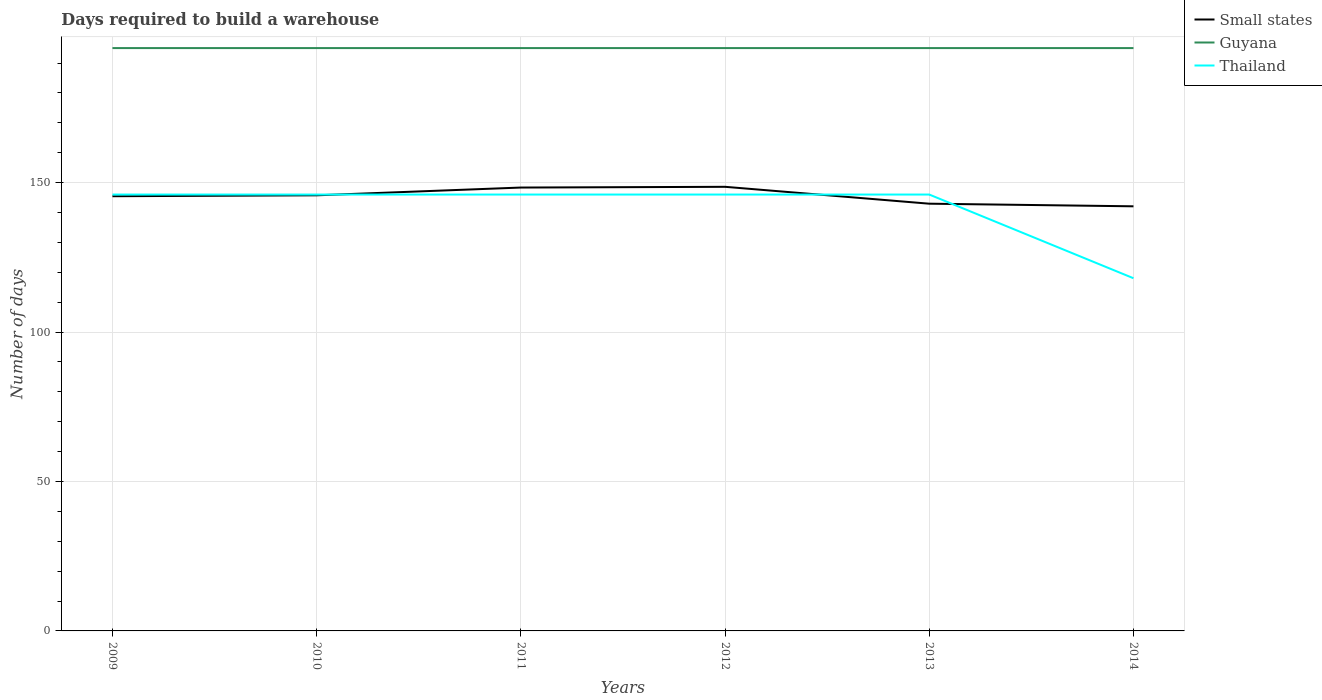Does the line corresponding to Guyana intersect with the line corresponding to Small states?
Provide a succinct answer. No. Across all years, what is the maximum days required to build a warehouse in in Guyana?
Provide a short and direct response. 195. What is the total days required to build a warehouse in in Guyana in the graph?
Give a very brief answer. 0. What is the difference between the highest and the second highest days required to build a warehouse in in Small states?
Your response must be concise. 6.53. What is the difference between the highest and the lowest days required to build a warehouse in in Small states?
Provide a short and direct response. 3. What is the difference between two consecutive major ticks on the Y-axis?
Keep it short and to the point. 50. Are the values on the major ticks of Y-axis written in scientific E-notation?
Keep it short and to the point. No. Does the graph contain any zero values?
Your answer should be compact. No. How many legend labels are there?
Offer a terse response. 3. How are the legend labels stacked?
Your answer should be very brief. Vertical. What is the title of the graph?
Make the answer very short. Days required to build a warehouse. What is the label or title of the Y-axis?
Give a very brief answer. Number of days. What is the Number of days of Small states in 2009?
Make the answer very short. 145.44. What is the Number of days in Guyana in 2009?
Offer a terse response. 195. What is the Number of days of Thailand in 2009?
Keep it short and to the point. 146. What is the Number of days in Small states in 2010?
Keep it short and to the point. 145.74. What is the Number of days of Guyana in 2010?
Make the answer very short. 195. What is the Number of days in Thailand in 2010?
Offer a terse response. 146. What is the Number of days in Small states in 2011?
Your answer should be very brief. 148.34. What is the Number of days in Guyana in 2011?
Your response must be concise. 195. What is the Number of days in Thailand in 2011?
Your answer should be compact. 146. What is the Number of days in Small states in 2012?
Your answer should be very brief. 148.59. What is the Number of days in Guyana in 2012?
Offer a very short reply. 195. What is the Number of days of Thailand in 2012?
Offer a terse response. 146. What is the Number of days of Small states in 2013?
Provide a short and direct response. 142.94. What is the Number of days in Guyana in 2013?
Offer a very short reply. 195. What is the Number of days in Thailand in 2013?
Keep it short and to the point. 146. What is the Number of days in Small states in 2014?
Make the answer very short. 142.06. What is the Number of days in Guyana in 2014?
Your response must be concise. 195. What is the Number of days in Thailand in 2014?
Offer a very short reply. 118. Across all years, what is the maximum Number of days in Small states?
Your response must be concise. 148.59. Across all years, what is the maximum Number of days of Guyana?
Provide a succinct answer. 195. Across all years, what is the maximum Number of days in Thailand?
Make the answer very short. 146. Across all years, what is the minimum Number of days of Small states?
Keep it short and to the point. 142.06. Across all years, what is the minimum Number of days in Guyana?
Your answer should be compact. 195. Across all years, what is the minimum Number of days of Thailand?
Give a very brief answer. 118. What is the total Number of days of Small states in the graph?
Your answer should be very brief. 873.1. What is the total Number of days in Guyana in the graph?
Make the answer very short. 1170. What is the total Number of days of Thailand in the graph?
Provide a short and direct response. 848. What is the difference between the Number of days of Small states in 2009 and that in 2010?
Offer a very short reply. -0.31. What is the difference between the Number of days of Thailand in 2009 and that in 2010?
Your response must be concise. 0. What is the difference between the Number of days of Small states in 2009 and that in 2011?
Provide a short and direct response. -2.9. What is the difference between the Number of days in Guyana in 2009 and that in 2011?
Give a very brief answer. 0. What is the difference between the Number of days of Thailand in 2009 and that in 2011?
Offer a very short reply. 0. What is the difference between the Number of days in Small states in 2009 and that in 2012?
Give a very brief answer. -3.15. What is the difference between the Number of days in Small states in 2009 and that in 2013?
Offer a very short reply. 2.5. What is the difference between the Number of days in Guyana in 2009 and that in 2013?
Provide a succinct answer. 0. What is the difference between the Number of days of Thailand in 2009 and that in 2013?
Your answer should be compact. 0. What is the difference between the Number of days in Small states in 2009 and that in 2014?
Give a very brief answer. 3.37. What is the difference between the Number of days of Thailand in 2009 and that in 2014?
Your answer should be very brief. 28. What is the difference between the Number of days of Small states in 2010 and that in 2011?
Keep it short and to the point. -2.59. What is the difference between the Number of days of Thailand in 2010 and that in 2011?
Your response must be concise. 0. What is the difference between the Number of days of Small states in 2010 and that in 2012?
Give a very brief answer. -2.84. What is the difference between the Number of days of Guyana in 2010 and that in 2012?
Keep it short and to the point. 0. What is the difference between the Number of days in Thailand in 2010 and that in 2012?
Your response must be concise. 0. What is the difference between the Number of days in Small states in 2010 and that in 2013?
Provide a short and direct response. 2.81. What is the difference between the Number of days of Thailand in 2010 and that in 2013?
Offer a terse response. 0. What is the difference between the Number of days in Small states in 2010 and that in 2014?
Make the answer very short. 3.68. What is the difference between the Number of days in Guyana in 2011 and that in 2012?
Your response must be concise. 0. What is the difference between the Number of days in Thailand in 2011 and that in 2012?
Give a very brief answer. 0. What is the difference between the Number of days in Small states in 2011 and that in 2014?
Make the answer very short. 6.28. What is the difference between the Number of days of Thailand in 2011 and that in 2014?
Your response must be concise. 28. What is the difference between the Number of days in Small states in 2012 and that in 2013?
Your answer should be very brief. 5.65. What is the difference between the Number of days of Guyana in 2012 and that in 2013?
Keep it short and to the point. 0. What is the difference between the Number of days in Thailand in 2012 and that in 2013?
Ensure brevity in your answer.  0. What is the difference between the Number of days in Small states in 2012 and that in 2014?
Ensure brevity in your answer.  6.53. What is the difference between the Number of days in Guyana in 2012 and that in 2014?
Your response must be concise. 0. What is the difference between the Number of days of Thailand in 2012 and that in 2014?
Your response must be concise. 28. What is the difference between the Number of days in Small states in 2009 and the Number of days in Guyana in 2010?
Provide a succinct answer. -49.56. What is the difference between the Number of days of Small states in 2009 and the Number of days of Thailand in 2010?
Ensure brevity in your answer.  -0.56. What is the difference between the Number of days of Small states in 2009 and the Number of days of Guyana in 2011?
Ensure brevity in your answer.  -49.56. What is the difference between the Number of days in Small states in 2009 and the Number of days in Thailand in 2011?
Your answer should be compact. -0.56. What is the difference between the Number of days in Guyana in 2009 and the Number of days in Thailand in 2011?
Provide a short and direct response. 49. What is the difference between the Number of days of Small states in 2009 and the Number of days of Guyana in 2012?
Ensure brevity in your answer.  -49.56. What is the difference between the Number of days in Small states in 2009 and the Number of days in Thailand in 2012?
Your response must be concise. -0.56. What is the difference between the Number of days in Small states in 2009 and the Number of days in Guyana in 2013?
Your answer should be very brief. -49.56. What is the difference between the Number of days of Small states in 2009 and the Number of days of Thailand in 2013?
Provide a succinct answer. -0.56. What is the difference between the Number of days of Guyana in 2009 and the Number of days of Thailand in 2013?
Ensure brevity in your answer.  49. What is the difference between the Number of days in Small states in 2009 and the Number of days in Guyana in 2014?
Make the answer very short. -49.56. What is the difference between the Number of days in Small states in 2009 and the Number of days in Thailand in 2014?
Provide a succinct answer. 27.44. What is the difference between the Number of days in Guyana in 2009 and the Number of days in Thailand in 2014?
Your answer should be very brief. 77. What is the difference between the Number of days in Small states in 2010 and the Number of days in Guyana in 2011?
Give a very brief answer. -49.26. What is the difference between the Number of days in Small states in 2010 and the Number of days in Thailand in 2011?
Keep it short and to the point. -0.26. What is the difference between the Number of days of Small states in 2010 and the Number of days of Guyana in 2012?
Ensure brevity in your answer.  -49.26. What is the difference between the Number of days in Small states in 2010 and the Number of days in Thailand in 2012?
Offer a terse response. -0.26. What is the difference between the Number of days of Small states in 2010 and the Number of days of Guyana in 2013?
Ensure brevity in your answer.  -49.26. What is the difference between the Number of days of Small states in 2010 and the Number of days of Thailand in 2013?
Your answer should be compact. -0.26. What is the difference between the Number of days of Guyana in 2010 and the Number of days of Thailand in 2013?
Your answer should be very brief. 49. What is the difference between the Number of days of Small states in 2010 and the Number of days of Guyana in 2014?
Make the answer very short. -49.26. What is the difference between the Number of days of Small states in 2010 and the Number of days of Thailand in 2014?
Offer a terse response. 27.74. What is the difference between the Number of days of Guyana in 2010 and the Number of days of Thailand in 2014?
Provide a succinct answer. 77. What is the difference between the Number of days of Small states in 2011 and the Number of days of Guyana in 2012?
Make the answer very short. -46.66. What is the difference between the Number of days of Small states in 2011 and the Number of days of Thailand in 2012?
Your answer should be very brief. 2.34. What is the difference between the Number of days in Guyana in 2011 and the Number of days in Thailand in 2012?
Keep it short and to the point. 49. What is the difference between the Number of days of Small states in 2011 and the Number of days of Guyana in 2013?
Your answer should be compact. -46.66. What is the difference between the Number of days in Small states in 2011 and the Number of days in Thailand in 2013?
Offer a very short reply. 2.34. What is the difference between the Number of days of Guyana in 2011 and the Number of days of Thailand in 2013?
Your response must be concise. 49. What is the difference between the Number of days in Small states in 2011 and the Number of days in Guyana in 2014?
Your answer should be compact. -46.66. What is the difference between the Number of days of Small states in 2011 and the Number of days of Thailand in 2014?
Your response must be concise. 30.34. What is the difference between the Number of days of Small states in 2012 and the Number of days of Guyana in 2013?
Ensure brevity in your answer.  -46.41. What is the difference between the Number of days in Small states in 2012 and the Number of days in Thailand in 2013?
Your answer should be very brief. 2.59. What is the difference between the Number of days in Guyana in 2012 and the Number of days in Thailand in 2013?
Give a very brief answer. 49. What is the difference between the Number of days in Small states in 2012 and the Number of days in Guyana in 2014?
Your answer should be compact. -46.41. What is the difference between the Number of days of Small states in 2012 and the Number of days of Thailand in 2014?
Keep it short and to the point. 30.59. What is the difference between the Number of days of Small states in 2013 and the Number of days of Guyana in 2014?
Offer a terse response. -52.06. What is the difference between the Number of days in Small states in 2013 and the Number of days in Thailand in 2014?
Provide a short and direct response. 24.94. What is the average Number of days of Small states per year?
Provide a short and direct response. 145.52. What is the average Number of days of Guyana per year?
Your answer should be compact. 195. What is the average Number of days of Thailand per year?
Your answer should be very brief. 141.33. In the year 2009, what is the difference between the Number of days of Small states and Number of days of Guyana?
Your answer should be very brief. -49.56. In the year 2009, what is the difference between the Number of days of Small states and Number of days of Thailand?
Your answer should be compact. -0.56. In the year 2010, what is the difference between the Number of days of Small states and Number of days of Guyana?
Ensure brevity in your answer.  -49.26. In the year 2010, what is the difference between the Number of days in Small states and Number of days in Thailand?
Offer a terse response. -0.26. In the year 2011, what is the difference between the Number of days in Small states and Number of days in Guyana?
Your response must be concise. -46.66. In the year 2011, what is the difference between the Number of days of Small states and Number of days of Thailand?
Ensure brevity in your answer.  2.34. In the year 2012, what is the difference between the Number of days in Small states and Number of days in Guyana?
Your answer should be compact. -46.41. In the year 2012, what is the difference between the Number of days in Small states and Number of days in Thailand?
Keep it short and to the point. 2.59. In the year 2013, what is the difference between the Number of days of Small states and Number of days of Guyana?
Provide a short and direct response. -52.06. In the year 2013, what is the difference between the Number of days in Small states and Number of days in Thailand?
Offer a terse response. -3.06. In the year 2013, what is the difference between the Number of days of Guyana and Number of days of Thailand?
Your answer should be very brief. 49. In the year 2014, what is the difference between the Number of days of Small states and Number of days of Guyana?
Offer a terse response. -52.94. In the year 2014, what is the difference between the Number of days in Small states and Number of days in Thailand?
Make the answer very short. 24.06. In the year 2014, what is the difference between the Number of days of Guyana and Number of days of Thailand?
Your answer should be very brief. 77. What is the ratio of the Number of days in Small states in 2009 to that in 2011?
Give a very brief answer. 0.98. What is the ratio of the Number of days in Guyana in 2009 to that in 2011?
Give a very brief answer. 1. What is the ratio of the Number of days of Small states in 2009 to that in 2012?
Ensure brevity in your answer.  0.98. What is the ratio of the Number of days in Small states in 2009 to that in 2013?
Make the answer very short. 1.02. What is the ratio of the Number of days in Thailand in 2009 to that in 2013?
Your answer should be very brief. 1. What is the ratio of the Number of days in Small states in 2009 to that in 2014?
Provide a succinct answer. 1.02. What is the ratio of the Number of days in Thailand in 2009 to that in 2014?
Ensure brevity in your answer.  1.24. What is the ratio of the Number of days in Small states in 2010 to that in 2011?
Your response must be concise. 0.98. What is the ratio of the Number of days of Thailand in 2010 to that in 2011?
Offer a very short reply. 1. What is the ratio of the Number of days in Small states in 2010 to that in 2012?
Your answer should be very brief. 0.98. What is the ratio of the Number of days in Guyana in 2010 to that in 2012?
Keep it short and to the point. 1. What is the ratio of the Number of days in Thailand in 2010 to that in 2012?
Make the answer very short. 1. What is the ratio of the Number of days of Small states in 2010 to that in 2013?
Provide a succinct answer. 1.02. What is the ratio of the Number of days in Small states in 2010 to that in 2014?
Your answer should be compact. 1.03. What is the ratio of the Number of days of Thailand in 2010 to that in 2014?
Offer a terse response. 1.24. What is the ratio of the Number of days of Small states in 2011 to that in 2012?
Keep it short and to the point. 1. What is the ratio of the Number of days of Guyana in 2011 to that in 2012?
Provide a succinct answer. 1. What is the ratio of the Number of days in Thailand in 2011 to that in 2012?
Your response must be concise. 1. What is the ratio of the Number of days in Small states in 2011 to that in 2013?
Give a very brief answer. 1.04. What is the ratio of the Number of days in Small states in 2011 to that in 2014?
Make the answer very short. 1.04. What is the ratio of the Number of days of Thailand in 2011 to that in 2014?
Offer a terse response. 1.24. What is the ratio of the Number of days of Small states in 2012 to that in 2013?
Provide a short and direct response. 1.04. What is the ratio of the Number of days of Thailand in 2012 to that in 2013?
Offer a terse response. 1. What is the ratio of the Number of days of Small states in 2012 to that in 2014?
Keep it short and to the point. 1.05. What is the ratio of the Number of days in Thailand in 2012 to that in 2014?
Keep it short and to the point. 1.24. What is the ratio of the Number of days of Thailand in 2013 to that in 2014?
Offer a very short reply. 1.24. What is the difference between the highest and the lowest Number of days of Small states?
Provide a short and direct response. 6.53. What is the difference between the highest and the lowest Number of days of Thailand?
Make the answer very short. 28. 